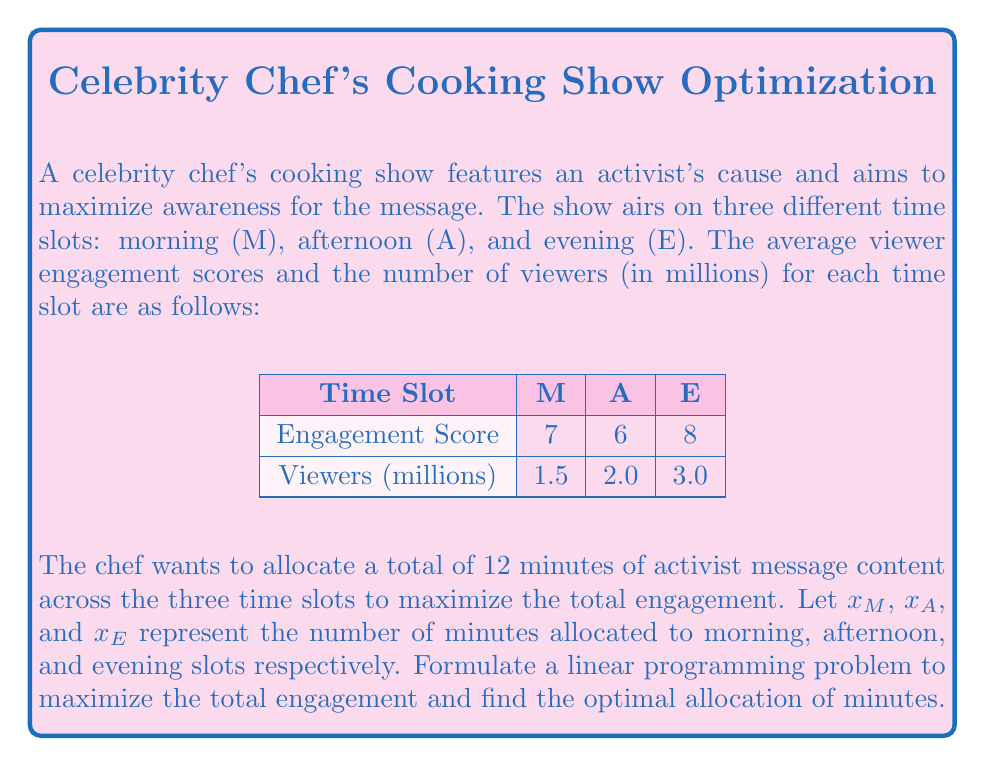Can you solve this math problem? To solve this linear programming problem, we'll follow these steps:

1) Define the objective function:
   The total engagement is the sum of (engagement score × number of viewers × allocated minutes) for each time slot.
   
   Objective function: Maximize 
   $$Z = 7 \times 1.5x_M + 6 \times 2.0x_A + 8 \times 3.0x_E$$
   $$Z = 10.5x_M + 12x_A + 24x_E$$

2) Define the constraints:
   a) The total allocated time must be 12 minutes:
      $$x_M + x_A + x_E = 12$$
   
   b) Non-negativity constraints:
      $$x_M \geq 0, x_A \geq 0, x_E \geq 0$$

3) Solve using the simplex method or graphical method:
   Given the simplicity of this problem, we can see that to maximize Z, we should allocate all 12 minutes to the time slot with the highest coefficient in the objective function.

4) The evening slot (E) has the highest coefficient (24), so the optimal solution is:
   $$x_M = 0, x_A = 0, x_E = 12$$

5) Calculate the maximum total engagement:
   $$Z_{max} = 10.5(0) + 12(0) + 24(12) = 288$$

Therefore, the optimal allocation is to put all 12 minutes of activist message content in the evening time slot, resulting in a maximum total engagement score of 288.
Answer: Evening: 12 minutes; Morning and Afternoon: 0 minutes. Maximum engagement: 288. 